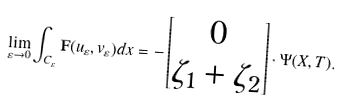Convert formula to latex. <formula><loc_0><loc_0><loc_500><loc_500>\lim _ { \varepsilon \rightarrow 0 } \int _ { C _ { \varepsilon } } { \mathbf F } ( u _ { \varepsilon } , v _ { \varepsilon } ) d x = - \left [ \begin{matrix} 0 \\ \zeta _ { 1 } + \zeta _ { 2 } \end{matrix} \right ] \cdot \Psi ( X , T ) .</formula> 